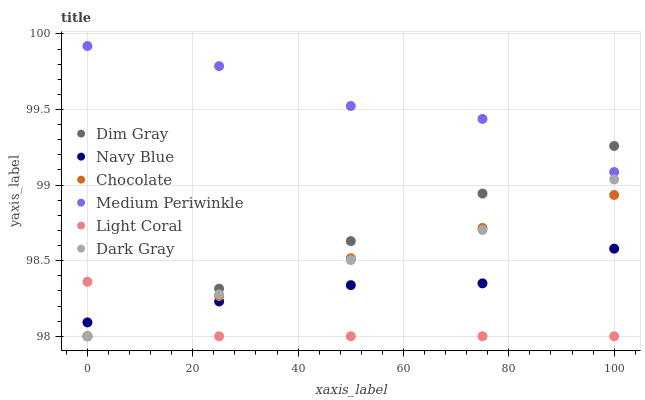Does Light Coral have the minimum area under the curve?
Answer yes or no. Yes. Does Medium Periwinkle have the maximum area under the curve?
Answer yes or no. Yes. Does Dim Gray have the minimum area under the curve?
Answer yes or no. No. Does Dim Gray have the maximum area under the curve?
Answer yes or no. No. Is Dim Gray the smoothest?
Answer yes or no. Yes. Is Medium Periwinkle the roughest?
Answer yes or no. Yes. Is Navy Blue the smoothest?
Answer yes or no. No. Is Navy Blue the roughest?
Answer yes or no. No. Does Dark Gray have the lowest value?
Answer yes or no. Yes. Does Navy Blue have the lowest value?
Answer yes or no. No. Does Medium Periwinkle have the highest value?
Answer yes or no. Yes. Does Dim Gray have the highest value?
Answer yes or no. No. Is Chocolate less than Medium Periwinkle?
Answer yes or no. Yes. Is Medium Periwinkle greater than Dark Gray?
Answer yes or no. Yes. Does Navy Blue intersect Chocolate?
Answer yes or no. Yes. Is Navy Blue less than Chocolate?
Answer yes or no. No. Is Navy Blue greater than Chocolate?
Answer yes or no. No. Does Chocolate intersect Medium Periwinkle?
Answer yes or no. No. 